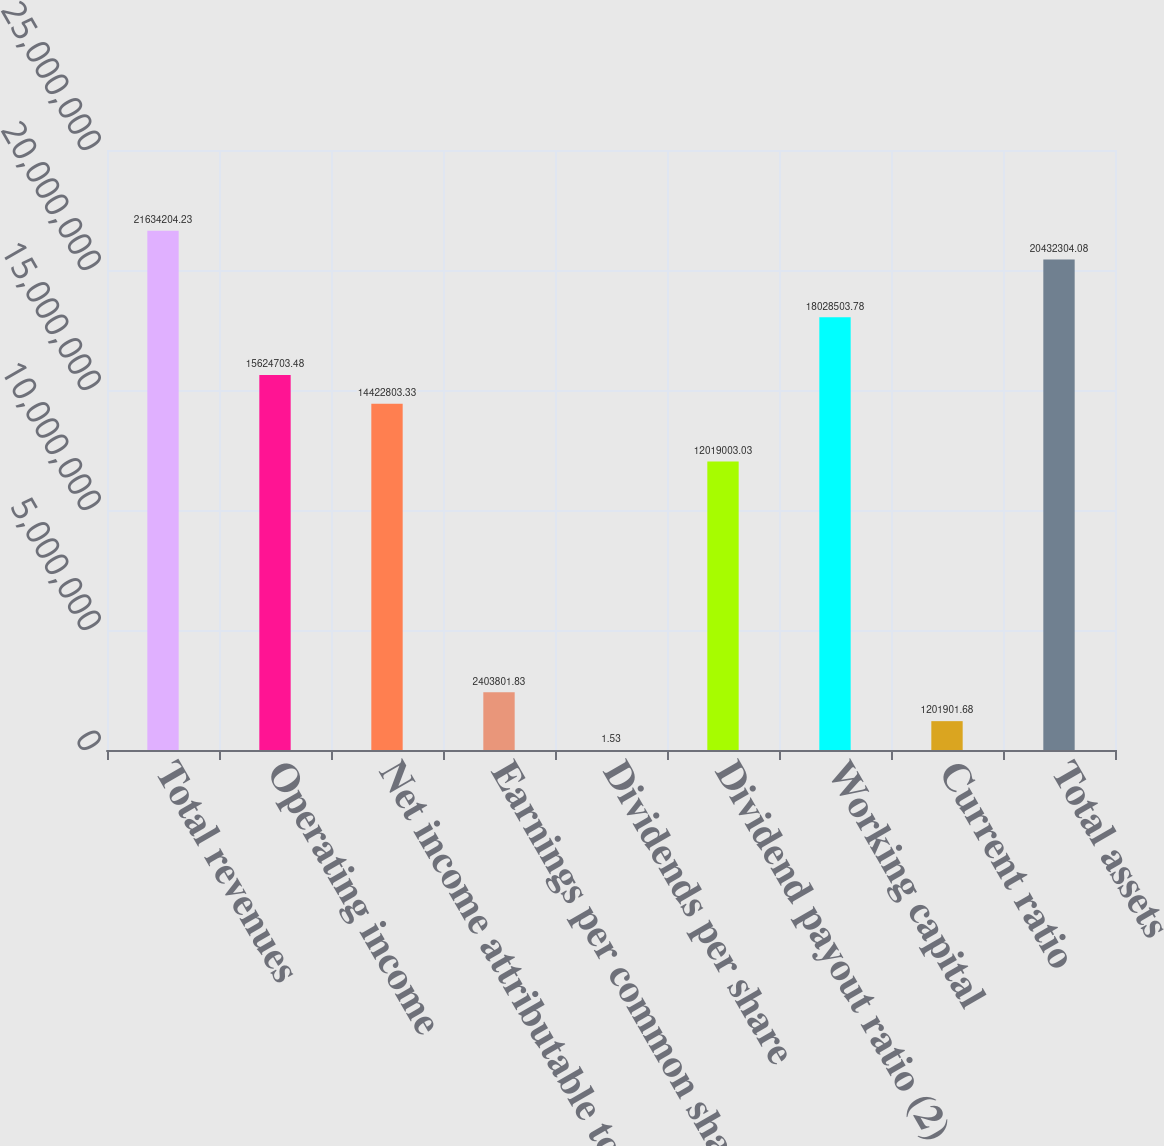Convert chart. <chart><loc_0><loc_0><loc_500><loc_500><bar_chart><fcel>Total revenues<fcel>Operating income<fcel>Net income attributable to VF<fcel>Earnings per common share<fcel>Dividends per share<fcel>Dividend payout ratio (2)<fcel>Working capital<fcel>Current ratio<fcel>Total assets<nl><fcel>2.16342e+07<fcel>1.56247e+07<fcel>1.44228e+07<fcel>2.4038e+06<fcel>1.53<fcel>1.2019e+07<fcel>1.80285e+07<fcel>1.2019e+06<fcel>2.04323e+07<nl></chart> 